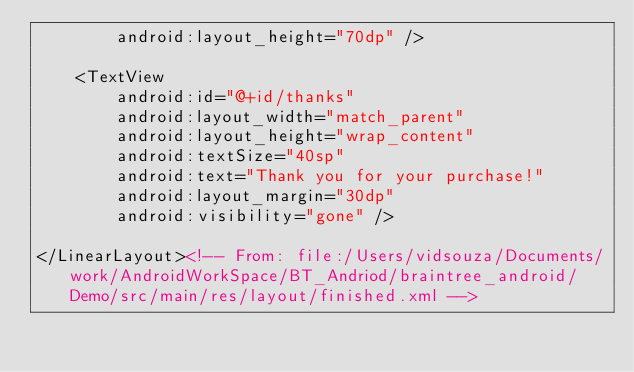Convert code to text. <code><loc_0><loc_0><loc_500><loc_500><_XML_>        android:layout_height="70dp" />

    <TextView
        android:id="@+id/thanks"
        android:layout_width="match_parent"
        android:layout_height="wrap_content"
        android:textSize="40sp"
        android:text="Thank you for your purchase!"
        android:layout_margin="30dp"
        android:visibility="gone" />

</LinearLayout><!-- From: file:/Users/vidsouza/Documents/work/AndroidWorkSpace/BT_Andriod/braintree_android/Demo/src/main/res/layout/finished.xml --></code> 